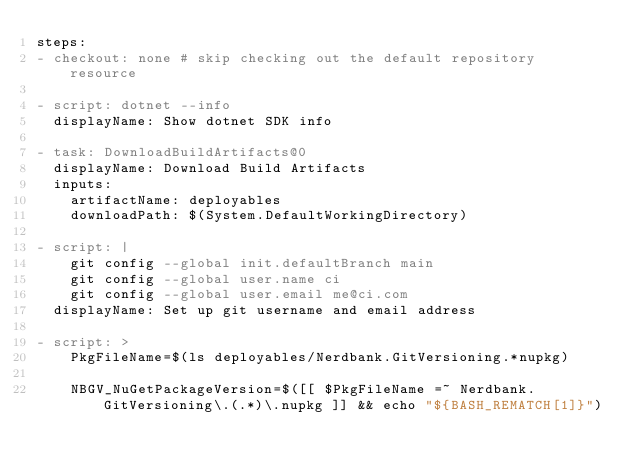Convert code to text. <code><loc_0><loc_0><loc_500><loc_500><_YAML_>steps:
- checkout: none # skip checking out the default repository resource

- script: dotnet --info
  displayName: Show dotnet SDK info

- task: DownloadBuildArtifacts@0
  displayName: Download Build Artifacts
  inputs:
    artifactName: deployables
    downloadPath: $(System.DefaultWorkingDirectory)

- script: |
    git config --global init.defaultBranch main
    git config --global user.name ci
    git config --global user.email me@ci.com
  displayName: Set up git username and email address

- script: >
    PkgFileName=$(ls deployables/Nerdbank.GitVersioning.*nupkg)

    NBGV_NuGetPackageVersion=$([[ $PkgFileName =~ Nerdbank.GitVersioning\.(.*)\.nupkg ]] && echo "${BASH_REMATCH[1]}")
</code> 